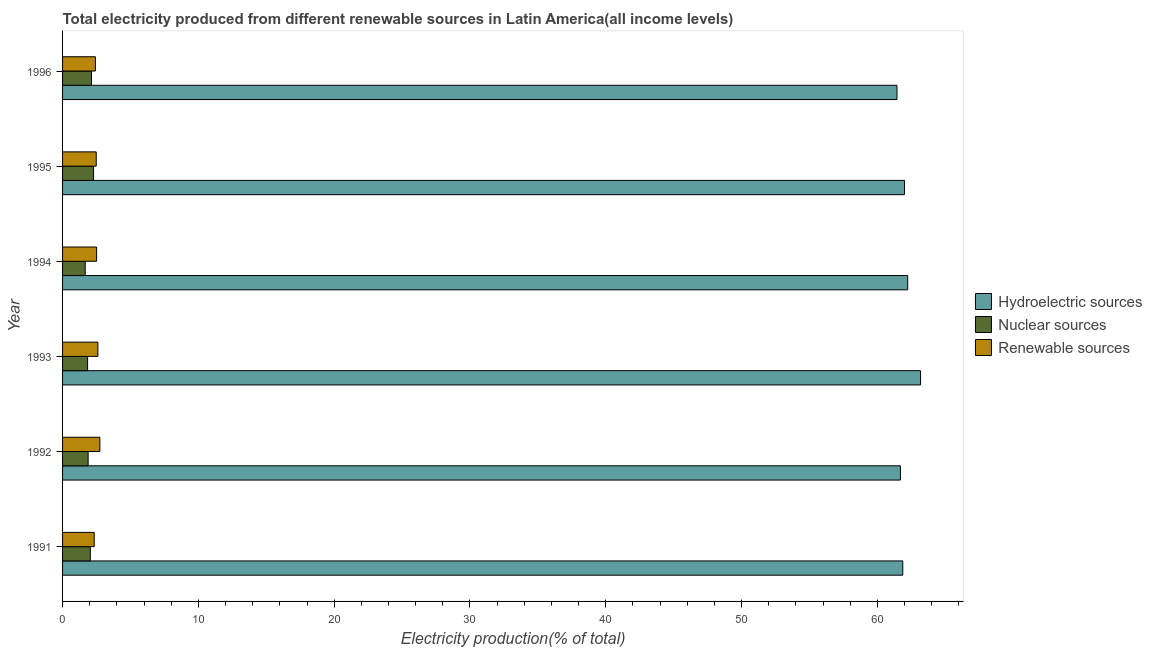How many different coloured bars are there?
Give a very brief answer. 3. Are the number of bars on each tick of the Y-axis equal?
Your answer should be very brief. Yes. How many bars are there on the 5th tick from the top?
Offer a terse response. 3. In how many cases, is the number of bars for a given year not equal to the number of legend labels?
Your response must be concise. 0. What is the percentage of electricity produced by renewable sources in 1991?
Make the answer very short. 2.33. Across all years, what is the maximum percentage of electricity produced by renewable sources?
Offer a terse response. 2.75. Across all years, what is the minimum percentage of electricity produced by nuclear sources?
Make the answer very short. 1.67. In which year was the percentage of electricity produced by hydroelectric sources maximum?
Your answer should be compact. 1993. What is the total percentage of electricity produced by hydroelectric sources in the graph?
Offer a very short reply. 372.42. What is the difference between the percentage of electricity produced by renewable sources in 1993 and that in 1994?
Your answer should be very brief. 0.09. What is the difference between the percentage of electricity produced by hydroelectric sources in 1991 and the percentage of electricity produced by renewable sources in 1996?
Provide a succinct answer. 59.45. What is the average percentage of electricity produced by nuclear sources per year?
Make the answer very short. 1.98. In the year 1991, what is the difference between the percentage of electricity produced by nuclear sources and percentage of electricity produced by renewable sources?
Ensure brevity in your answer.  -0.29. What is the ratio of the percentage of electricity produced by hydroelectric sources in 1994 to that in 1995?
Offer a very short reply. 1. What is the difference between the highest and the second highest percentage of electricity produced by renewable sources?
Provide a short and direct response. 0.14. What is the difference between the highest and the lowest percentage of electricity produced by hydroelectric sources?
Provide a succinct answer. 1.74. Is the sum of the percentage of electricity produced by nuclear sources in 1993 and 1994 greater than the maximum percentage of electricity produced by hydroelectric sources across all years?
Provide a short and direct response. No. What does the 2nd bar from the top in 1995 represents?
Provide a short and direct response. Nuclear sources. What does the 2nd bar from the bottom in 1991 represents?
Your answer should be very brief. Nuclear sources. How many bars are there?
Provide a short and direct response. 18. Are all the bars in the graph horizontal?
Make the answer very short. Yes. What is the difference between two consecutive major ticks on the X-axis?
Your answer should be compact. 10. Does the graph contain grids?
Make the answer very short. No. Where does the legend appear in the graph?
Offer a very short reply. Center right. What is the title of the graph?
Make the answer very short. Total electricity produced from different renewable sources in Latin America(all income levels). Does "Agricultural raw materials" appear as one of the legend labels in the graph?
Provide a short and direct response. No. What is the label or title of the Y-axis?
Ensure brevity in your answer.  Year. What is the Electricity production(% of total) of Hydroelectric sources in 1991?
Provide a short and direct response. 61.87. What is the Electricity production(% of total) in Nuclear sources in 1991?
Offer a terse response. 2.04. What is the Electricity production(% of total) in Renewable sources in 1991?
Your answer should be very brief. 2.33. What is the Electricity production(% of total) of Hydroelectric sources in 1992?
Offer a very short reply. 61.7. What is the Electricity production(% of total) in Nuclear sources in 1992?
Provide a succinct answer. 1.88. What is the Electricity production(% of total) of Renewable sources in 1992?
Offer a terse response. 2.75. What is the Electricity production(% of total) of Hydroelectric sources in 1993?
Provide a short and direct response. 63.18. What is the Electricity production(% of total) of Nuclear sources in 1993?
Ensure brevity in your answer.  1.84. What is the Electricity production(% of total) of Renewable sources in 1993?
Give a very brief answer. 2.6. What is the Electricity production(% of total) in Hydroelectric sources in 1994?
Your response must be concise. 62.23. What is the Electricity production(% of total) in Nuclear sources in 1994?
Your response must be concise. 1.67. What is the Electricity production(% of total) in Renewable sources in 1994?
Keep it short and to the point. 2.51. What is the Electricity production(% of total) of Hydroelectric sources in 1995?
Keep it short and to the point. 62. What is the Electricity production(% of total) in Nuclear sources in 1995?
Offer a very short reply. 2.28. What is the Electricity production(% of total) of Renewable sources in 1995?
Offer a terse response. 2.48. What is the Electricity production(% of total) of Hydroelectric sources in 1996?
Make the answer very short. 61.44. What is the Electricity production(% of total) of Nuclear sources in 1996?
Offer a terse response. 2.13. What is the Electricity production(% of total) of Renewable sources in 1996?
Your response must be concise. 2.42. Across all years, what is the maximum Electricity production(% of total) of Hydroelectric sources?
Provide a short and direct response. 63.18. Across all years, what is the maximum Electricity production(% of total) in Nuclear sources?
Your answer should be compact. 2.28. Across all years, what is the maximum Electricity production(% of total) of Renewable sources?
Your answer should be very brief. 2.75. Across all years, what is the minimum Electricity production(% of total) of Hydroelectric sources?
Make the answer very short. 61.44. Across all years, what is the minimum Electricity production(% of total) of Nuclear sources?
Make the answer very short. 1.67. Across all years, what is the minimum Electricity production(% of total) of Renewable sources?
Provide a short and direct response. 2.33. What is the total Electricity production(% of total) in Hydroelectric sources in the graph?
Your response must be concise. 372.42. What is the total Electricity production(% of total) of Nuclear sources in the graph?
Provide a short and direct response. 11.85. What is the total Electricity production(% of total) in Renewable sources in the graph?
Your answer should be very brief. 15.08. What is the difference between the Electricity production(% of total) of Hydroelectric sources in 1991 and that in 1992?
Provide a short and direct response. 0.17. What is the difference between the Electricity production(% of total) of Nuclear sources in 1991 and that in 1992?
Offer a very short reply. 0.16. What is the difference between the Electricity production(% of total) in Renewable sources in 1991 and that in 1992?
Your answer should be compact. -0.42. What is the difference between the Electricity production(% of total) of Hydroelectric sources in 1991 and that in 1993?
Offer a very short reply. -1.31. What is the difference between the Electricity production(% of total) of Nuclear sources in 1991 and that in 1993?
Ensure brevity in your answer.  0.2. What is the difference between the Electricity production(% of total) of Renewable sources in 1991 and that in 1993?
Make the answer very short. -0.27. What is the difference between the Electricity production(% of total) in Hydroelectric sources in 1991 and that in 1994?
Your response must be concise. -0.36. What is the difference between the Electricity production(% of total) in Nuclear sources in 1991 and that in 1994?
Provide a succinct answer. 0.38. What is the difference between the Electricity production(% of total) of Renewable sources in 1991 and that in 1994?
Offer a terse response. -0.18. What is the difference between the Electricity production(% of total) in Hydroelectric sources in 1991 and that in 1995?
Provide a succinct answer. -0.13. What is the difference between the Electricity production(% of total) of Nuclear sources in 1991 and that in 1995?
Your answer should be compact. -0.24. What is the difference between the Electricity production(% of total) of Renewable sources in 1991 and that in 1995?
Ensure brevity in your answer.  -0.15. What is the difference between the Electricity production(% of total) of Hydroelectric sources in 1991 and that in 1996?
Provide a succinct answer. 0.43. What is the difference between the Electricity production(% of total) of Nuclear sources in 1991 and that in 1996?
Give a very brief answer. -0.09. What is the difference between the Electricity production(% of total) of Renewable sources in 1991 and that in 1996?
Offer a terse response. -0.09. What is the difference between the Electricity production(% of total) of Hydroelectric sources in 1992 and that in 1993?
Provide a succinct answer. -1.48. What is the difference between the Electricity production(% of total) in Nuclear sources in 1992 and that in 1993?
Your answer should be very brief. 0.04. What is the difference between the Electricity production(% of total) in Renewable sources in 1992 and that in 1993?
Keep it short and to the point. 0.14. What is the difference between the Electricity production(% of total) in Hydroelectric sources in 1992 and that in 1994?
Keep it short and to the point. -0.54. What is the difference between the Electricity production(% of total) in Nuclear sources in 1992 and that in 1994?
Your answer should be very brief. 0.22. What is the difference between the Electricity production(% of total) in Renewable sources in 1992 and that in 1994?
Your answer should be compact. 0.24. What is the difference between the Electricity production(% of total) of Hydroelectric sources in 1992 and that in 1995?
Make the answer very short. -0.3. What is the difference between the Electricity production(% of total) in Nuclear sources in 1992 and that in 1995?
Your response must be concise. -0.4. What is the difference between the Electricity production(% of total) in Renewable sources in 1992 and that in 1995?
Offer a very short reply. 0.27. What is the difference between the Electricity production(% of total) of Hydroelectric sources in 1992 and that in 1996?
Ensure brevity in your answer.  0.25. What is the difference between the Electricity production(% of total) of Nuclear sources in 1992 and that in 1996?
Give a very brief answer. -0.25. What is the difference between the Electricity production(% of total) in Renewable sources in 1992 and that in 1996?
Your response must be concise. 0.33. What is the difference between the Electricity production(% of total) of Hydroelectric sources in 1993 and that in 1994?
Your response must be concise. 0.95. What is the difference between the Electricity production(% of total) in Nuclear sources in 1993 and that in 1994?
Provide a short and direct response. 0.18. What is the difference between the Electricity production(% of total) in Renewable sources in 1993 and that in 1994?
Give a very brief answer. 0.09. What is the difference between the Electricity production(% of total) in Hydroelectric sources in 1993 and that in 1995?
Ensure brevity in your answer.  1.18. What is the difference between the Electricity production(% of total) in Nuclear sources in 1993 and that in 1995?
Ensure brevity in your answer.  -0.44. What is the difference between the Electricity production(% of total) in Renewable sources in 1993 and that in 1995?
Provide a short and direct response. 0.12. What is the difference between the Electricity production(% of total) in Hydroelectric sources in 1993 and that in 1996?
Ensure brevity in your answer.  1.74. What is the difference between the Electricity production(% of total) in Nuclear sources in 1993 and that in 1996?
Keep it short and to the point. -0.29. What is the difference between the Electricity production(% of total) of Renewable sources in 1993 and that in 1996?
Keep it short and to the point. 0.18. What is the difference between the Electricity production(% of total) of Hydroelectric sources in 1994 and that in 1995?
Offer a very short reply. 0.24. What is the difference between the Electricity production(% of total) of Nuclear sources in 1994 and that in 1995?
Provide a succinct answer. -0.61. What is the difference between the Electricity production(% of total) of Renewable sources in 1994 and that in 1995?
Your answer should be very brief. 0.03. What is the difference between the Electricity production(% of total) in Hydroelectric sources in 1994 and that in 1996?
Make the answer very short. 0.79. What is the difference between the Electricity production(% of total) of Nuclear sources in 1994 and that in 1996?
Your response must be concise. -0.46. What is the difference between the Electricity production(% of total) in Renewable sources in 1994 and that in 1996?
Keep it short and to the point. 0.09. What is the difference between the Electricity production(% of total) in Hydroelectric sources in 1995 and that in 1996?
Make the answer very short. 0.55. What is the difference between the Electricity production(% of total) of Nuclear sources in 1995 and that in 1996?
Ensure brevity in your answer.  0.15. What is the difference between the Electricity production(% of total) of Renewable sources in 1995 and that in 1996?
Your answer should be compact. 0.06. What is the difference between the Electricity production(% of total) of Hydroelectric sources in 1991 and the Electricity production(% of total) of Nuclear sources in 1992?
Your response must be concise. 59.99. What is the difference between the Electricity production(% of total) of Hydroelectric sources in 1991 and the Electricity production(% of total) of Renewable sources in 1992?
Give a very brief answer. 59.12. What is the difference between the Electricity production(% of total) in Nuclear sources in 1991 and the Electricity production(% of total) in Renewable sources in 1992?
Offer a terse response. -0.7. What is the difference between the Electricity production(% of total) in Hydroelectric sources in 1991 and the Electricity production(% of total) in Nuclear sources in 1993?
Offer a very short reply. 60.03. What is the difference between the Electricity production(% of total) in Hydroelectric sources in 1991 and the Electricity production(% of total) in Renewable sources in 1993?
Make the answer very short. 59.27. What is the difference between the Electricity production(% of total) in Nuclear sources in 1991 and the Electricity production(% of total) in Renewable sources in 1993?
Your answer should be very brief. -0.56. What is the difference between the Electricity production(% of total) of Hydroelectric sources in 1991 and the Electricity production(% of total) of Nuclear sources in 1994?
Provide a succinct answer. 60.2. What is the difference between the Electricity production(% of total) in Hydroelectric sources in 1991 and the Electricity production(% of total) in Renewable sources in 1994?
Give a very brief answer. 59.36. What is the difference between the Electricity production(% of total) in Nuclear sources in 1991 and the Electricity production(% of total) in Renewable sources in 1994?
Ensure brevity in your answer.  -0.46. What is the difference between the Electricity production(% of total) of Hydroelectric sources in 1991 and the Electricity production(% of total) of Nuclear sources in 1995?
Offer a very short reply. 59.59. What is the difference between the Electricity production(% of total) in Hydroelectric sources in 1991 and the Electricity production(% of total) in Renewable sources in 1995?
Ensure brevity in your answer.  59.39. What is the difference between the Electricity production(% of total) of Nuclear sources in 1991 and the Electricity production(% of total) of Renewable sources in 1995?
Make the answer very short. -0.44. What is the difference between the Electricity production(% of total) of Hydroelectric sources in 1991 and the Electricity production(% of total) of Nuclear sources in 1996?
Your answer should be very brief. 59.74. What is the difference between the Electricity production(% of total) in Hydroelectric sources in 1991 and the Electricity production(% of total) in Renewable sources in 1996?
Keep it short and to the point. 59.45. What is the difference between the Electricity production(% of total) of Nuclear sources in 1991 and the Electricity production(% of total) of Renewable sources in 1996?
Provide a succinct answer. -0.37. What is the difference between the Electricity production(% of total) of Hydroelectric sources in 1992 and the Electricity production(% of total) of Nuclear sources in 1993?
Make the answer very short. 59.85. What is the difference between the Electricity production(% of total) in Hydroelectric sources in 1992 and the Electricity production(% of total) in Renewable sources in 1993?
Provide a short and direct response. 59.1. What is the difference between the Electricity production(% of total) in Nuclear sources in 1992 and the Electricity production(% of total) in Renewable sources in 1993?
Keep it short and to the point. -0.72. What is the difference between the Electricity production(% of total) of Hydroelectric sources in 1992 and the Electricity production(% of total) of Nuclear sources in 1994?
Your answer should be compact. 60.03. What is the difference between the Electricity production(% of total) in Hydroelectric sources in 1992 and the Electricity production(% of total) in Renewable sources in 1994?
Your answer should be compact. 59.19. What is the difference between the Electricity production(% of total) of Nuclear sources in 1992 and the Electricity production(% of total) of Renewable sources in 1994?
Offer a very short reply. -0.62. What is the difference between the Electricity production(% of total) of Hydroelectric sources in 1992 and the Electricity production(% of total) of Nuclear sources in 1995?
Offer a very short reply. 59.42. What is the difference between the Electricity production(% of total) of Hydroelectric sources in 1992 and the Electricity production(% of total) of Renewable sources in 1995?
Make the answer very short. 59.22. What is the difference between the Electricity production(% of total) of Nuclear sources in 1992 and the Electricity production(% of total) of Renewable sources in 1995?
Ensure brevity in your answer.  -0.6. What is the difference between the Electricity production(% of total) of Hydroelectric sources in 1992 and the Electricity production(% of total) of Nuclear sources in 1996?
Make the answer very short. 59.57. What is the difference between the Electricity production(% of total) of Hydroelectric sources in 1992 and the Electricity production(% of total) of Renewable sources in 1996?
Your answer should be compact. 59.28. What is the difference between the Electricity production(% of total) of Nuclear sources in 1992 and the Electricity production(% of total) of Renewable sources in 1996?
Offer a terse response. -0.54. What is the difference between the Electricity production(% of total) in Hydroelectric sources in 1993 and the Electricity production(% of total) in Nuclear sources in 1994?
Your answer should be very brief. 61.51. What is the difference between the Electricity production(% of total) of Hydroelectric sources in 1993 and the Electricity production(% of total) of Renewable sources in 1994?
Keep it short and to the point. 60.67. What is the difference between the Electricity production(% of total) of Nuclear sources in 1993 and the Electricity production(% of total) of Renewable sources in 1994?
Offer a very short reply. -0.66. What is the difference between the Electricity production(% of total) in Hydroelectric sources in 1993 and the Electricity production(% of total) in Nuclear sources in 1995?
Keep it short and to the point. 60.9. What is the difference between the Electricity production(% of total) in Hydroelectric sources in 1993 and the Electricity production(% of total) in Renewable sources in 1995?
Your answer should be compact. 60.7. What is the difference between the Electricity production(% of total) in Nuclear sources in 1993 and the Electricity production(% of total) in Renewable sources in 1995?
Your answer should be very brief. -0.64. What is the difference between the Electricity production(% of total) of Hydroelectric sources in 1993 and the Electricity production(% of total) of Nuclear sources in 1996?
Offer a very short reply. 61.05. What is the difference between the Electricity production(% of total) of Hydroelectric sources in 1993 and the Electricity production(% of total) of Renewable sources in 1996?
Ensure brevity in your answer.  60.76. What is the difference between the Electricity production(% of total) of Nuclear sources in 1993 and the Electricity production(% of total) of Renewable sources in 1996?
Your answer should be compact. -0.57. What is the difference between the Electricity production(% of total) in Hydroelectric sources in 1994 and the Electricity production(% of total) in Nuclear sources in 1995?
Offer a terse response. 59.95. What is the difference between the Electricity production(% of total) of Hydroelectric sources in 1994 and the Electricity production(% of total) of Renewable sources in 1995?
Your answer should be compact. 59.75. What is the difference between the Electricity production(% of total) of Nuclear sources in 1994 and the Electricity production(% of total) of Renewable sources in 1995?
Your answer should be compact. -0.81. What is the difference between the Electricity production(% of total) of Hydroelectric sources in 1994 and the Electricity production(% of total) of Nuclear sources in 1996?
Ensure brevity in your answer.  60.1. What is the difference between the Electricity production(% of total) of Hydroelectric sources in 1994 and the Electricity production(% of total) of Renewable sources in 1996?
Ensure brevity in your answer.  59.82. What is the difference between the Electricity production(% of total) in Nuclear sources in 1994 and the Electricity production(% of total) in Renewable sources in 1996?
Your response must be concise. -0.75. What is the difference between the Electricity production(% of total) in Hydroelectric sources in 1995 and the Electricity production(% of total) in Nuclear sources in 1996?
Offer a terse response. 59.87. What is the difference between the Electricity production(% of total) in Hydroelectric sources in 1995 and the Electricity production(% of total) in Renewable sources in 1996?
Offer a terse response. 59.58. What is the difference between the Electricity production(% of total) in Nuclear sources in 1995 and the Electricity production(% of total) in Renewable sources in 1996?
Make the answer very short. -0.14. What is the average Electricity production(% of total) of Hydroelectric sources per year?
Ensure brevity in your answer.  62.07. What is the average Electricity production(% of total) in Nuclear sources per year?
Provide a succinct answer. 1.98. What is the average Electricity production(% of total) in Renewable sources per year?
Make the answer very short. 2.51. In the year 1991, what is the difference between the Electricity production(% of total) in Hydroelectric sources and Electricity production(% of total) in Nuclear sources?
Keep it short and to the point. 59.83. In the year 1991, what is the difference between the Electricity production(% of total) in Hydroelectric sources and Electricity production(% of total) in Renewable sources?
Keep it short and to the point. 59.54. In the year 1991, what is the difference between the Electricity production(% of total) of Nuclear sources and Electricity production(% of total) of Renewable sources?
Offer a terse response. -0.29. In the year 1992, what is the difference between the Electricity production(% of total) of Hydroelectric sources and Electricity production(% of total) of Nuclear sources?
Provide a short and direct response. 59.81. In the year 1992, what is the difference between the Electricity production(% of total) in Hydroelectric sources and Electricity production(% of total) in Renewable sources?
Make the answer very short. 58.95. In the year 1992, what is the difference between the Electricity production(% of total) in Nuclear sources and Electricity production(% of total) in Renewable sources?
Offer a very short reply. -0.86. In the year 1993, what is the difference between the Electricity production(% of total) in Hydroelectric sources and Electricity production(% of total) in Nuclear sources?
Ensure brevity in your answer.  61.34. In the year 1993, what is the difference between the Electricity production(% of total) of Hydroelectric sources and Electricity production(% of total) of Renewable sources?
Make the answer very short. 60.58. In the year 1993, what is the difference between the Electricity production(% of total) in Nuclear sources and Electricity production(% of total) in Renewable sources?
Offer a very short reply. -0.76. In the year 1994, what is the difference between the Electricity production(% of total) in Hydroelectric sources and Electricity production(% of total) in Nuclear sources?
Your response must be concise. 60.57. In the year 1994, what is the difference between the Electricity production(% of total) of Hydroelectric sources and Electricity production(% of total) of Renewable sources?
Ensure brevity in your answer.  59.73. In the year 1994, what is the difference between the Electricity production(% of total) of Nuclear sources and Electricity production(% of total) of Renewable sources?
Offer a terse response. -0.84. In the year 1995, what is the difference between the Electricity production(% of total) in Hydroelectric sources and Electricity production(% of total) in Nuclear sources?
Offer a very short reply. 59.72. In the year 1995, what is the difference between the Electricity production(% of total) in Hydroelectric sources and Electricity production(% of total) in Renewable sources?
Make the answer very short. 59.52. In the year 1995, what is the difference between the Electricity production(% of total) in Nuclear sources and Electricity production(% of total) in Renewable sources?
Make the answer very short. -0.2. In the year 1996, what is the difference between the Electricity production(% of total) of Hydroelectric sources and Electricity production(% of total) of Nuclear sources?
Provide a short and direct response. 59.31. In the year 1996, what is the difference between the Electricity production(% of total) in Hydroelectric sources and Electricity production(% of total) in Renewable sources?
Offer a terse response. 59.03. In the year 1996, what is the difference between the Electricity production(% of total) in Nuclear sources and Electricity production(% of total) in Renewable sources?
Provide a short and direct response. -0.29. What is the ratio of the Electricity production(% of total) of Hydroelectric sources in 1991 to that in 1992?
Provide a succinct answer. 1. What is the ratio of the Electricity production(% of total) in Nuclear sources in 1991 to that in 1992?
Your response must be concise. 1.08. What is the ratio of the Electricity production(% of total) in Renewable sources in 1991 to that in 1992?
Your answer should be compact. 0.85. What is the ratio of the Electricity production(% of total) of Hydroelectric sources in 1991 to that in 1993?
Your response must be concise. 0.98. What is the ratio of the Electricity production(% of total) of Nuclear sources in 1991 to that in 1993?
Ensure brevity in your answer.  1.11. What is the ratio of the Electricity production(% of total) in Renewable sources in 1991 to that in 1993?
Ensure brevity in your answer.  0.9. What is the ratio of the Electricity production(% of total) of Hydroelectric sources in 1991 to that in 1994?
Keep it short and to the point. 0.99. What is the ratio of the Electricity production(% of total) in Nuclear sources in 1991 to that in 1994?
Provide a short and direct response. 1.23. What is the ratio of the Electricity production(% of total) in Renewable sources in 1991 to that in 1994?
Offer a terse response. 0.93. What is the ratio of the Electricity production(% of total) of Hydroelectric sources in 1991 to that in 1995?
Your answer should be compact. 1. What is the ratio of the Electricity production(% of total) of Nuclear sources in 1991 to that in 1995?
Your response must be concise. 0.9. What is the ratio of the Electricity production(% of total) in Renewable sources in 1991 to that in 1995?
Ensure brevity in your answer.  0.94. What is the ratio of the Electricity production(% of total) in Nuclear sources in 1991 to that in 1996?
Give a very brief answer. 0.96. What is the ratio of the Electricity production(% of total) in Renewable sources in 1991 to that in 1996?
Provide a short and direct response. 0.96. What is the ratio of the Electricity production(% of total) of Hydroelectric sources in 1992 to that in 1993?
Ensure brevity in your answer.  0.98. What is the ratio of the Electricity production(% of total) in Nuclear sources in 1992 to that in 1993?
Your answer should be compact. 1.02. What is the ratio of the Electricity production(% of total) of Renewable sources in 1992 to that in 1993?
Give a very brief answer. 1.06. What is the ratio of the Electricity production(% of total) in Nuclear sources in 1992 to that in 1994?
Keep it short and to the point. 1.13. What is the ratio of the Electricity production(% of total) in Renewable sources in 1992 to that in 1994?
Your answer should be compact. 1.1. What is the ratio of the Electricity production(% of total) of Hydroelectric sources in 1992 to that in 1995?
Provide a short and direct response. 1. What is the ratio of the Electricity production(% of total) of Nuclear sources in 1992 to that in 1995?
Provide a succinct answer. 0.83. What is the ratio of the Electricity production(% of total) in Renewable sources in 1992 to that in 1995?
Provide a short and direct response. 1.11. What is the ratio of the Electricity production(% of total) of Nuclear sources in 1992 to that in 1996?
Make the answer very short. 0.88. What is the ratio of the Electricity production(% of total) of Renewable sources in 1992 to that in 1996?
Offer a terse response. 1.14. What is the ratio of the Electricity production(% of total) in Hydroelectric sources in 1993 to that in 1994?
Make the answer very short. 1.02. What is the ratio of the Electricity production(% of total) in Nuclear sources in 1993 to that in 1994?
Offer a very short reply. 1.11. What is the ratio of the Electricity production(% of total) of Renewable sources in 1993 to that in 1994?
Ensure brevity in your answer.  1.04. What is the ratio of the Electricity production(% of total) in Hydroelectric sources in 1993 to that in 1995?
Provide a succinct answer. 1.02. What is the ratio of the Electricity production(% of total) in Nuclear sources in 1993 to that in 1995?
Ensure brevity in your answer.  0.81. What is the ratio of the Electricity production(% of total) of Renewable sources in 1993 to that in 1995?
Make the answer very short. 1.05. What is the ratio of the Electricity production(% of total) of Hydroelectric sources in 1993 to that in 1996?
Your answer should be very brief. 1.03. What is the ratio of the Electricity production(% of total) of Nuclear sources in 1993 to that in 1996?
Your response must be concise. 0.87. What is the ratio of the Electricity production(% of total) in Renewable sources in 1993 to that in 1996?
Offer a very short reply. 1.08. What is the ratio of the Electricity production(% of total) of Nuclear sources in 1994 to that in 1995?
Make the answer very short. 0.73. What is the ratio of the Electricity production(% of total) in Renewable sources in 1994 to that in 1995?
Offer a terse response. 1.01. What is the ratio of the Electricity production(% of total) in Hydroelectric sources in 1994 to that in 1996?
Your response must be concise. 1.01. What is the ratio of the Electricity production(% of total) in Nuclear sources in 1994 to that in 1996?
Offer a terse response. 0.78. What is the ratio of the Electricity production(% of total) of Renewable sources in 1994 to that in 1996?
Make the answer very short. 1.04. What is the ratio of the Electricity production(% of total) in Hydroelectric sources in 1995 to that in 1996?
Offer a terse response. 1.01. What is the ratio of the Electricity production(% of total) in Nuclear sources in 1995 to that in 1996?
Offer a very short reply. 1.07. What is the ratio of the Electricity production(% of total) of Renewable sources in 1995 to that in 1996?
Make the answer very short. 1.03. What is the difference between the highest and the second highest Electricity production(% of total) of Hydroelectric sources?
Offer a very short reply. 0.95. What is the difference between the highest and the second highest Electricity production(% of total) in Nuclear sources?
Give a very brief answer. 0.15. What is the difference between the highest and the second highest Electricity production(% of total) of Renewable sources?
Offer a very short reply. 0.14. What is the difference between the highest and the lowest Electricity production(% of total) of Hydroelectric sources?
Your answer should be very brief. 1.74. What is the difference between the highest and the lowest Electricity production(% of total) of Nuclear sources?
Offer a terse response. 0.61. What is the difference between the highest and the lowest Electricity production(% of total) of Renewable sources?
Offer a very short reply. 0.42. 